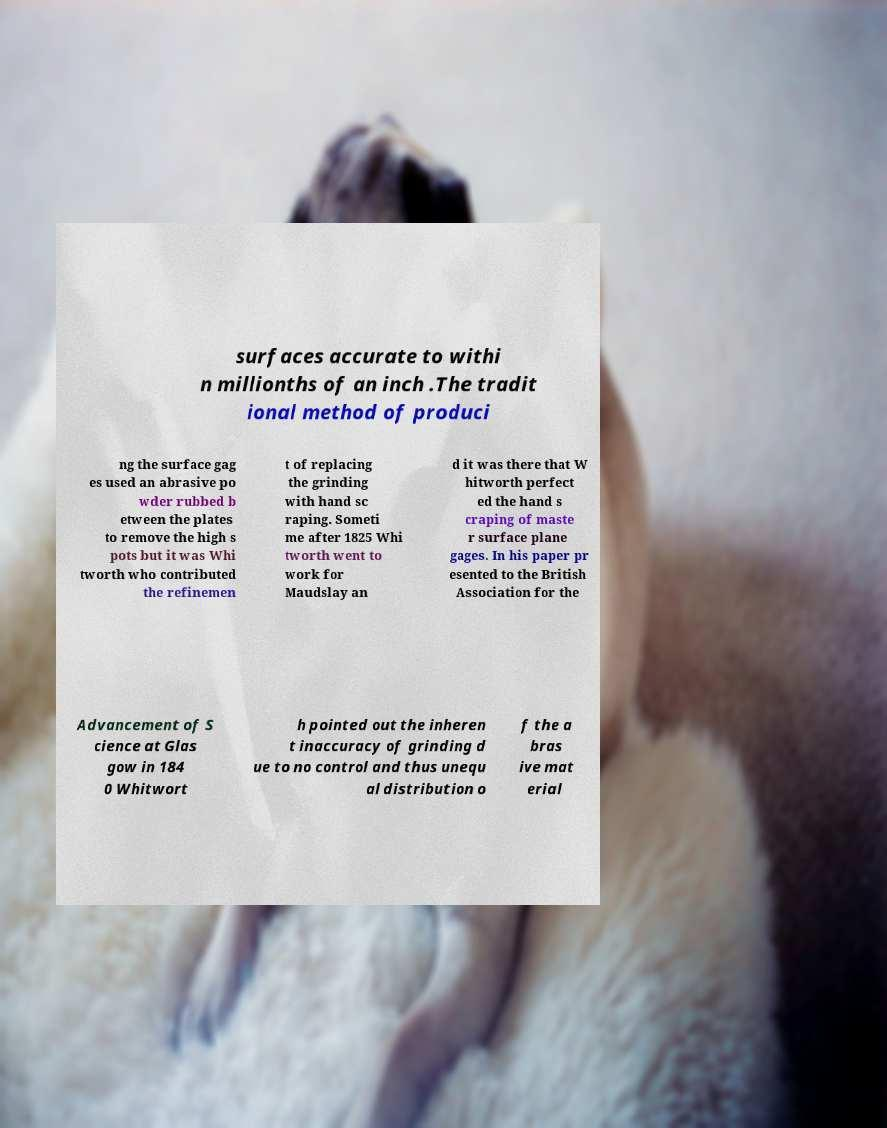For documentation purposes, I need the text within this image transcribed. Could you provide that? surfaces accurate to withi n millionths of an inch .The tradit ional method of produci ng the surface gag es used an abrasive po wder rubbed b etween the plates to remove the high s pots but it was Whi tworth who contributed the refinemen t of replacing the grinding with hand sc raping. Someti me after 1825 Whi tworth went to work for Maudslay an d it was there that W hitworth perfect ed the hand s craping of maste r surface plane gages. In his paper pr esented to the British Association for the Advancement of S cience at Glas gow in 184 0 Whitwort h pointed out the inheren t inaccuracy of grinding d ue to no control and thus unequ al distribution o f the a bras ive mat erial 